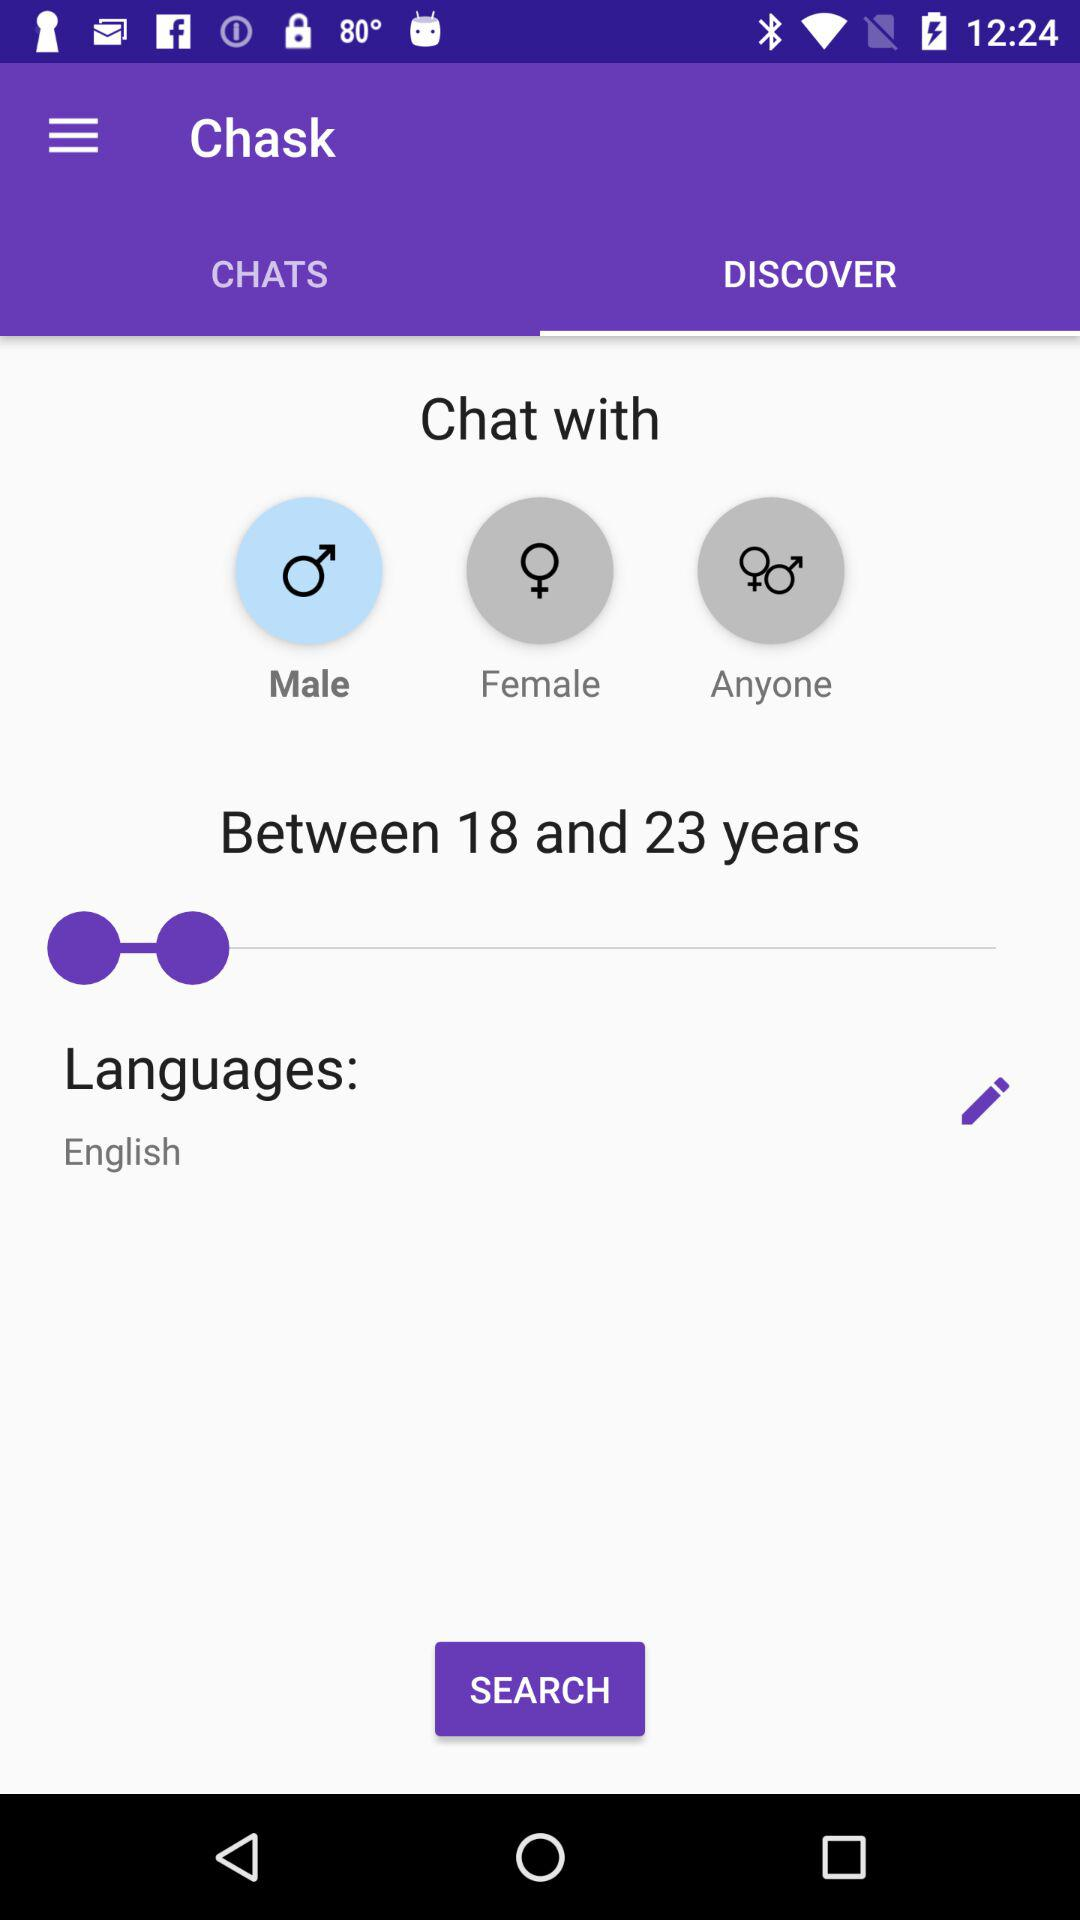How many years does the age range span?
Answer the question using a single word or phrase. 5 